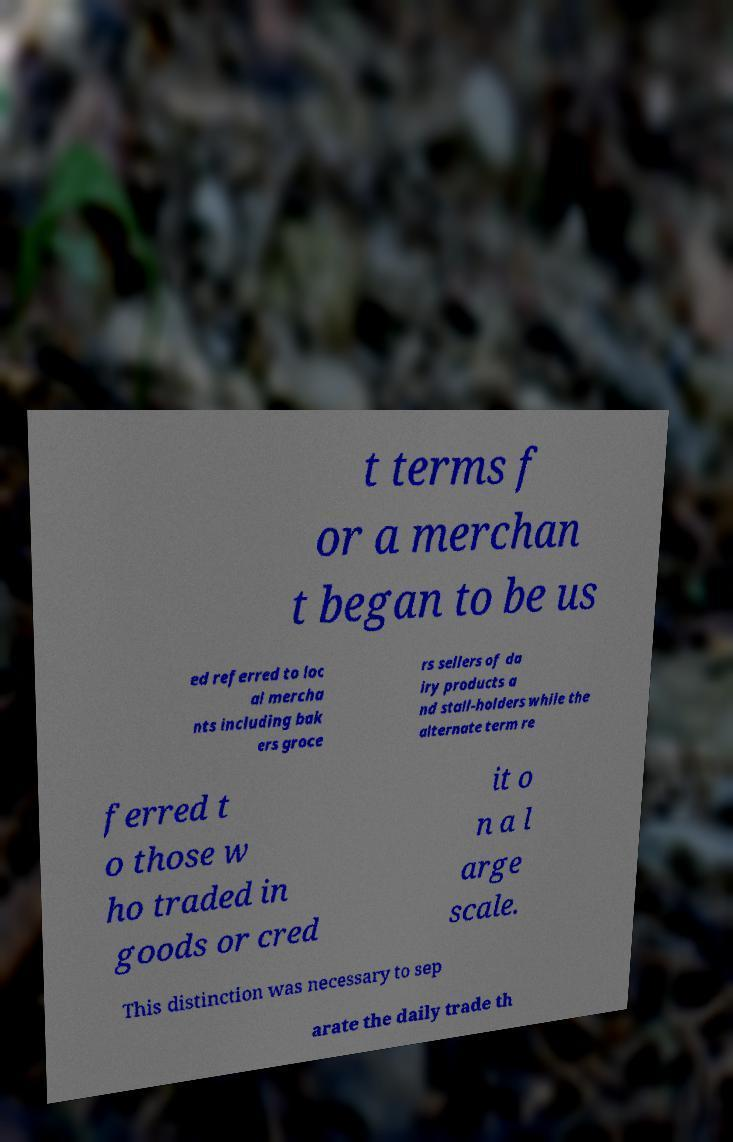Can you read and provide the text displayed in the image?This photo seems to have some interesting text. Can you extract and type it out for me? t terms f or a merchan t began to be us ed referred to loc al mercha nts including bak ers groce rs sellers of da iry products a nd stall-holders while the alternate term re ferred t o those w ho traded in goods or cred it o n a l arge scale. This distinction was necessary to sep arate the daily trade th 